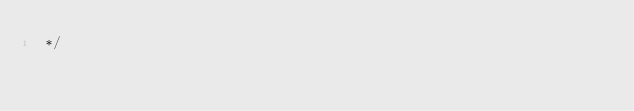Convert code to text. <code><loc_0><loc_0><loc_500><loc_500><_CSS_> */</code> 